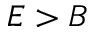<formula> <loc_0><loc_0><loc_500><loc_500>E > B</formula> 